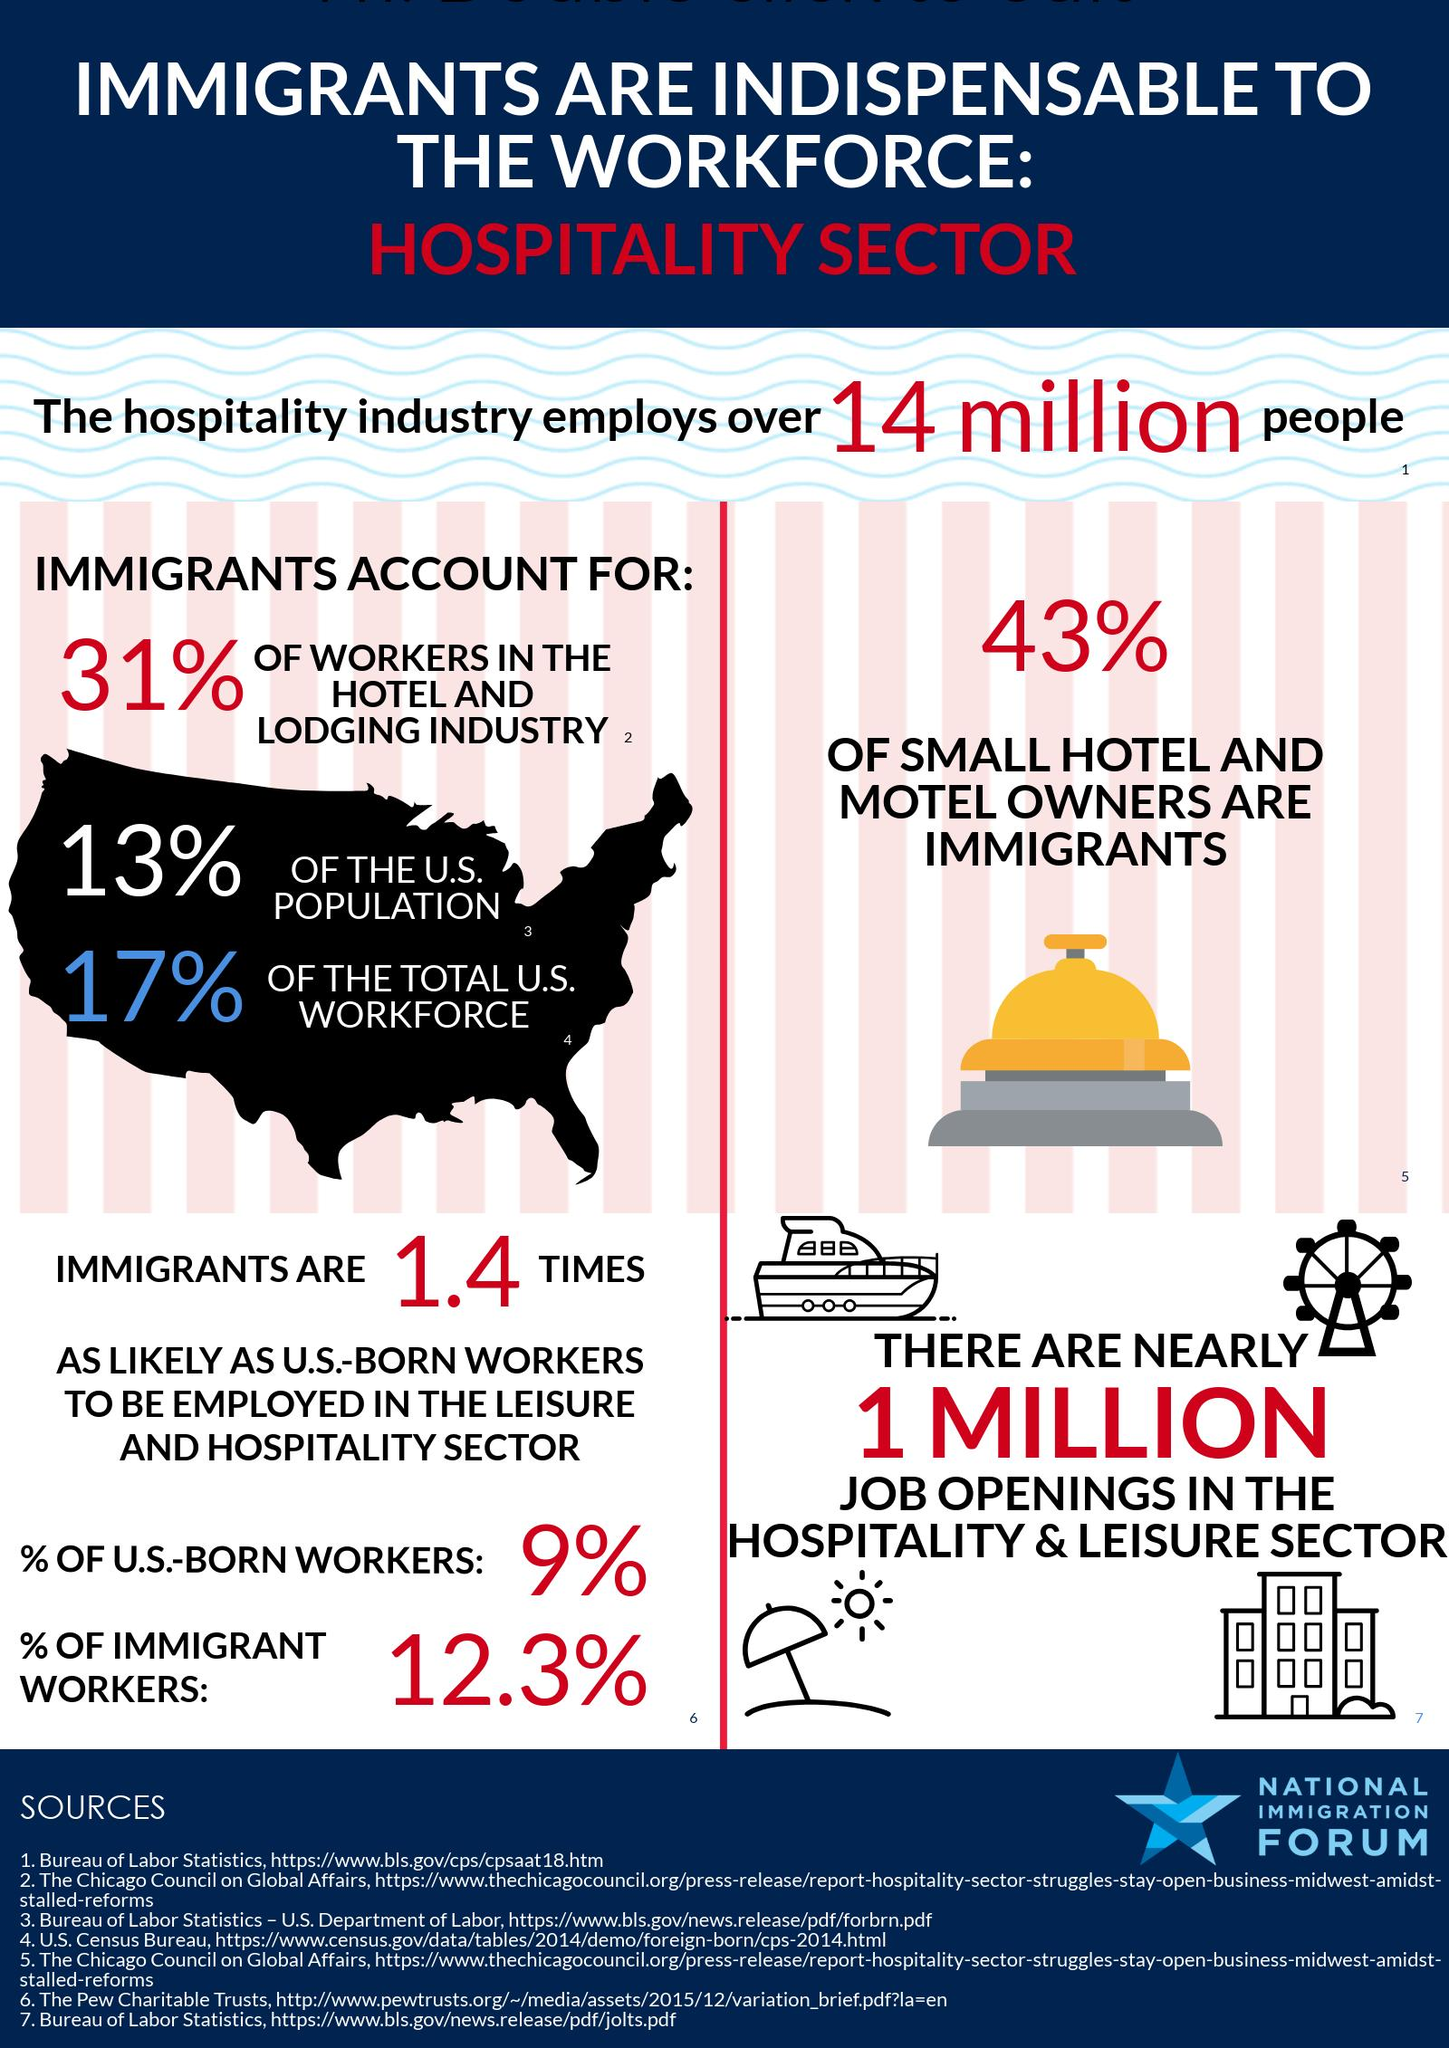Identify some key points in this picture. According to the given data, approximately 21.3% of workers in the Hospitality sector in the United States are either born in the United States or are immigrants. 